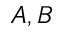Convert formula to latex. <formula><loc_0><loc_0><loc_500><loc_500>A , B</formula> 